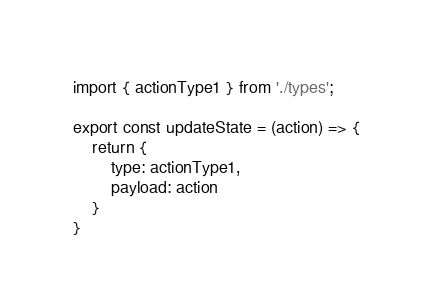Convert code to text. <code><loc_0><loc_0><loc_500><loc_500><_JavaScript_>import { actionType1 } from './types';

export const updateState = (action) => {
    return {
        type: actionType1,
        payload: action
    }
}</code> 